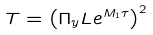Convert formula to latex. <formula><loc_0><loc_0><loc_500><loc_500>T = \left ( \Pi _ { y } L e ^ { M _ { 1 } \tau } \right ) ^ { 2 } \,</formula> 